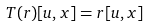<formula> <loc_0><loc_0><loc_500><loc_500>T ( r ) [ u , x ] = r [ u , x ]</formula> 